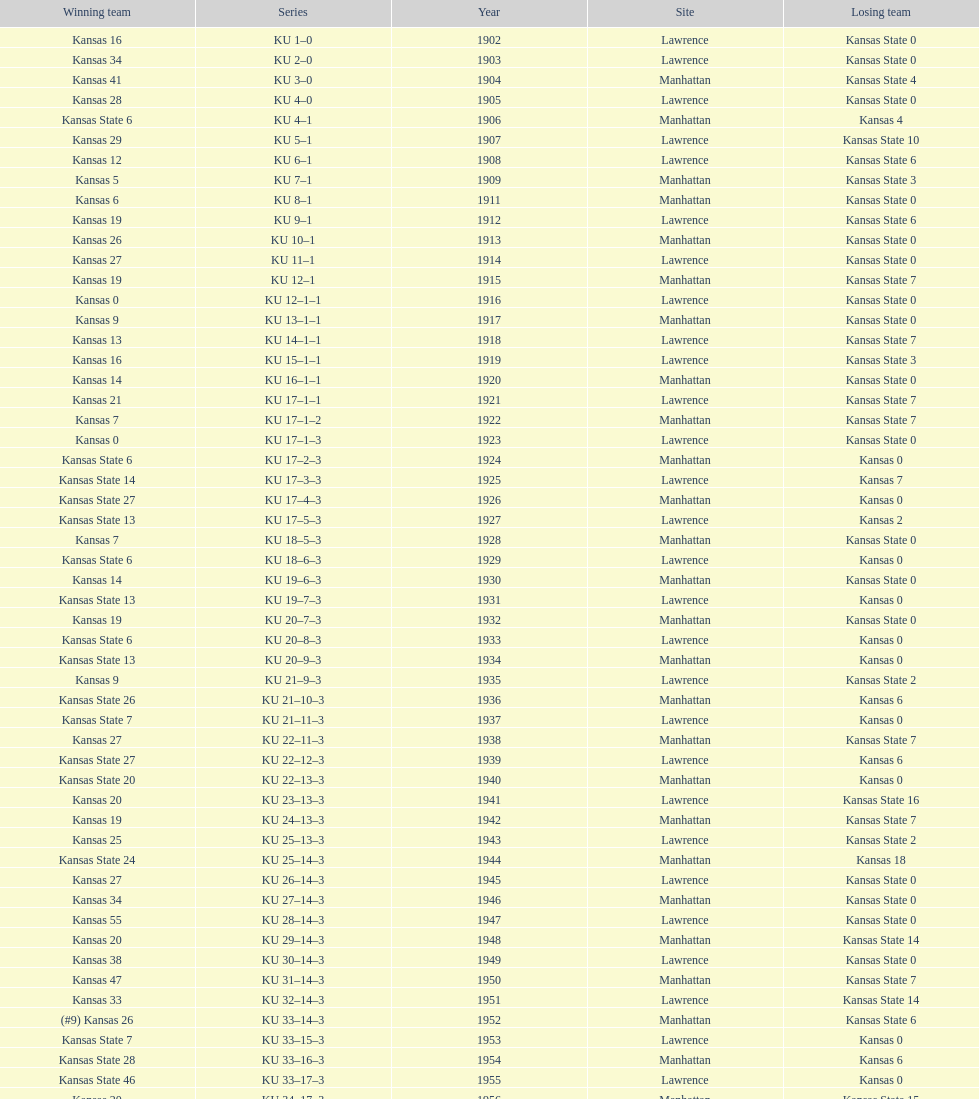How many times did kansas state not score at all against kansas from 1902-1968? 23. 